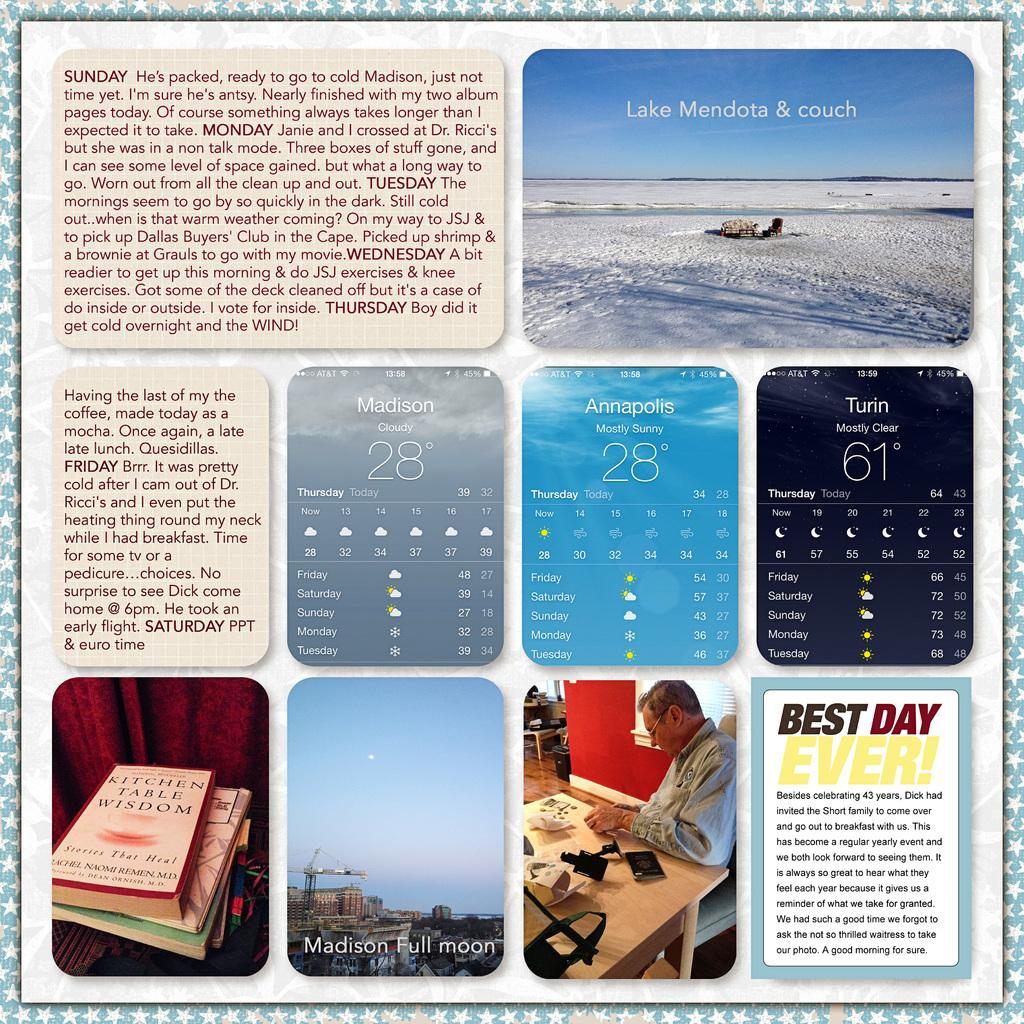Provide a one-sentence caption for the provided image. A collection of different pictures featuring the weather, the Best Day Ever and other things. 